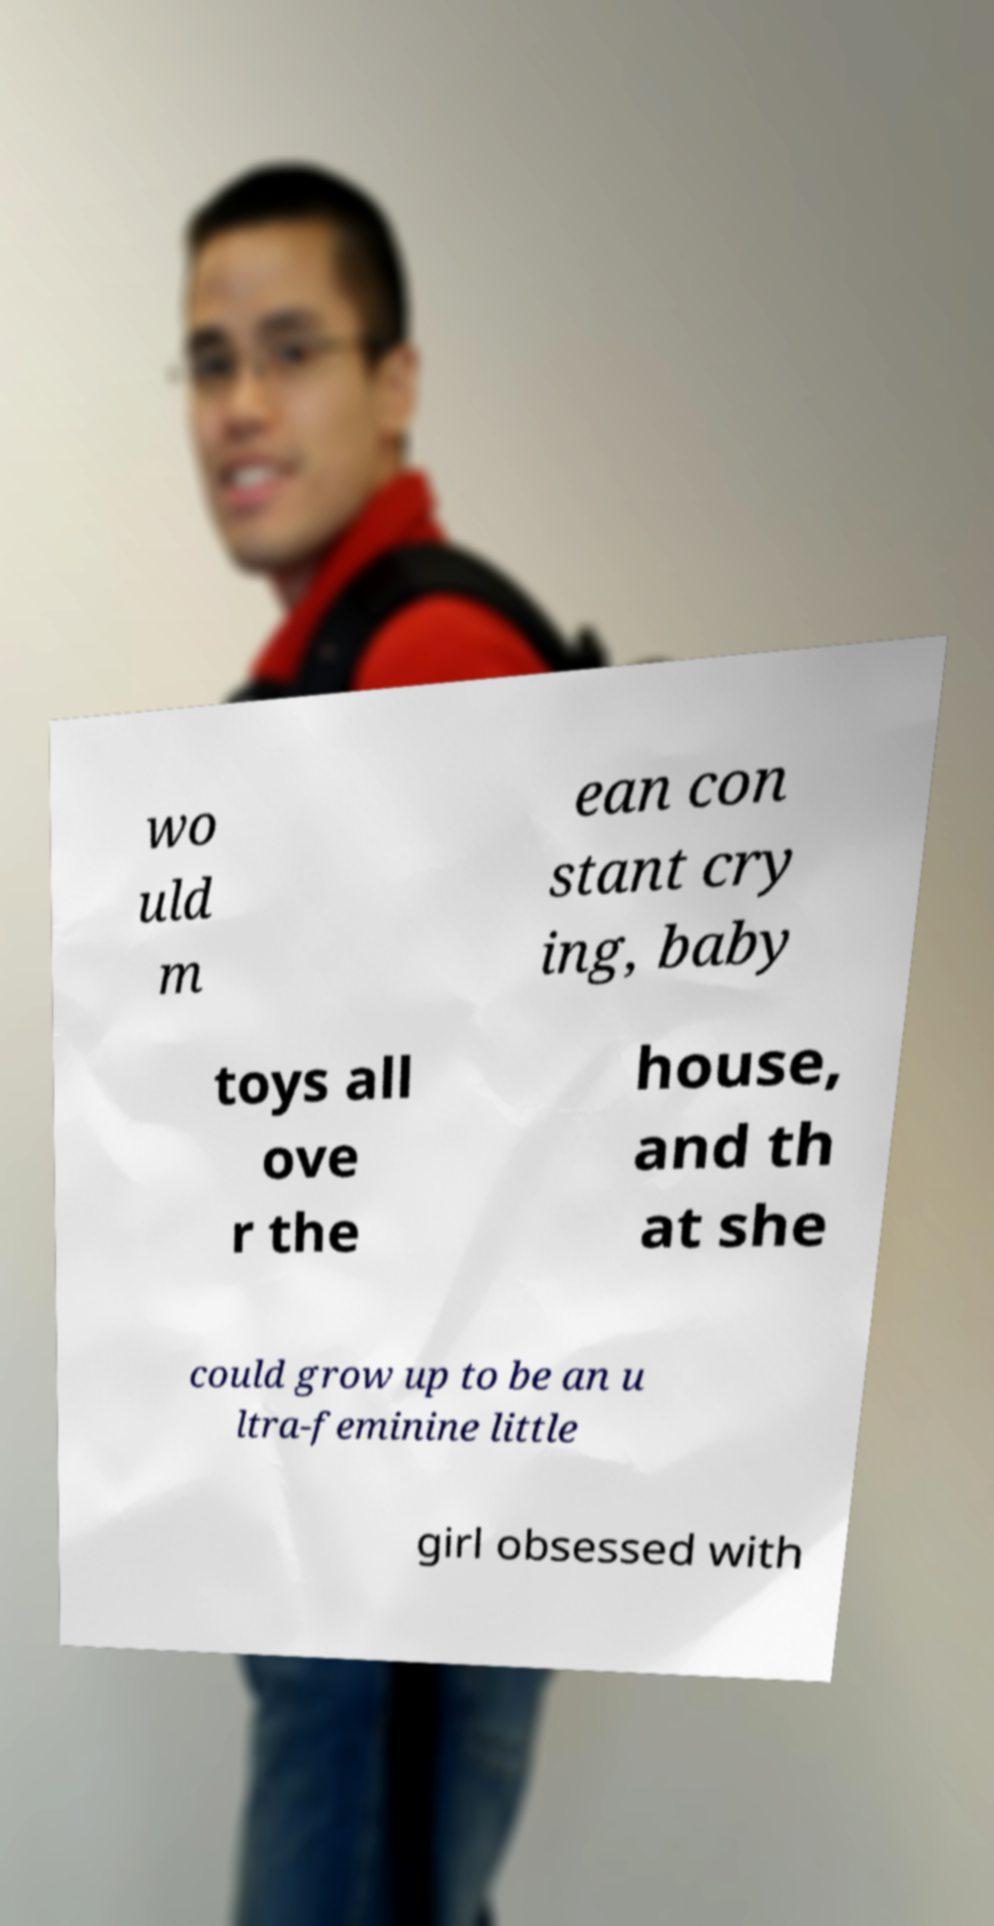I need the written content from this picture converted into text. Can you do that? wo uld m ean con stant cry ing, baby toys all ove r the house, and th at she could grow up to be an u ltra-feminine little girl obsessed with 